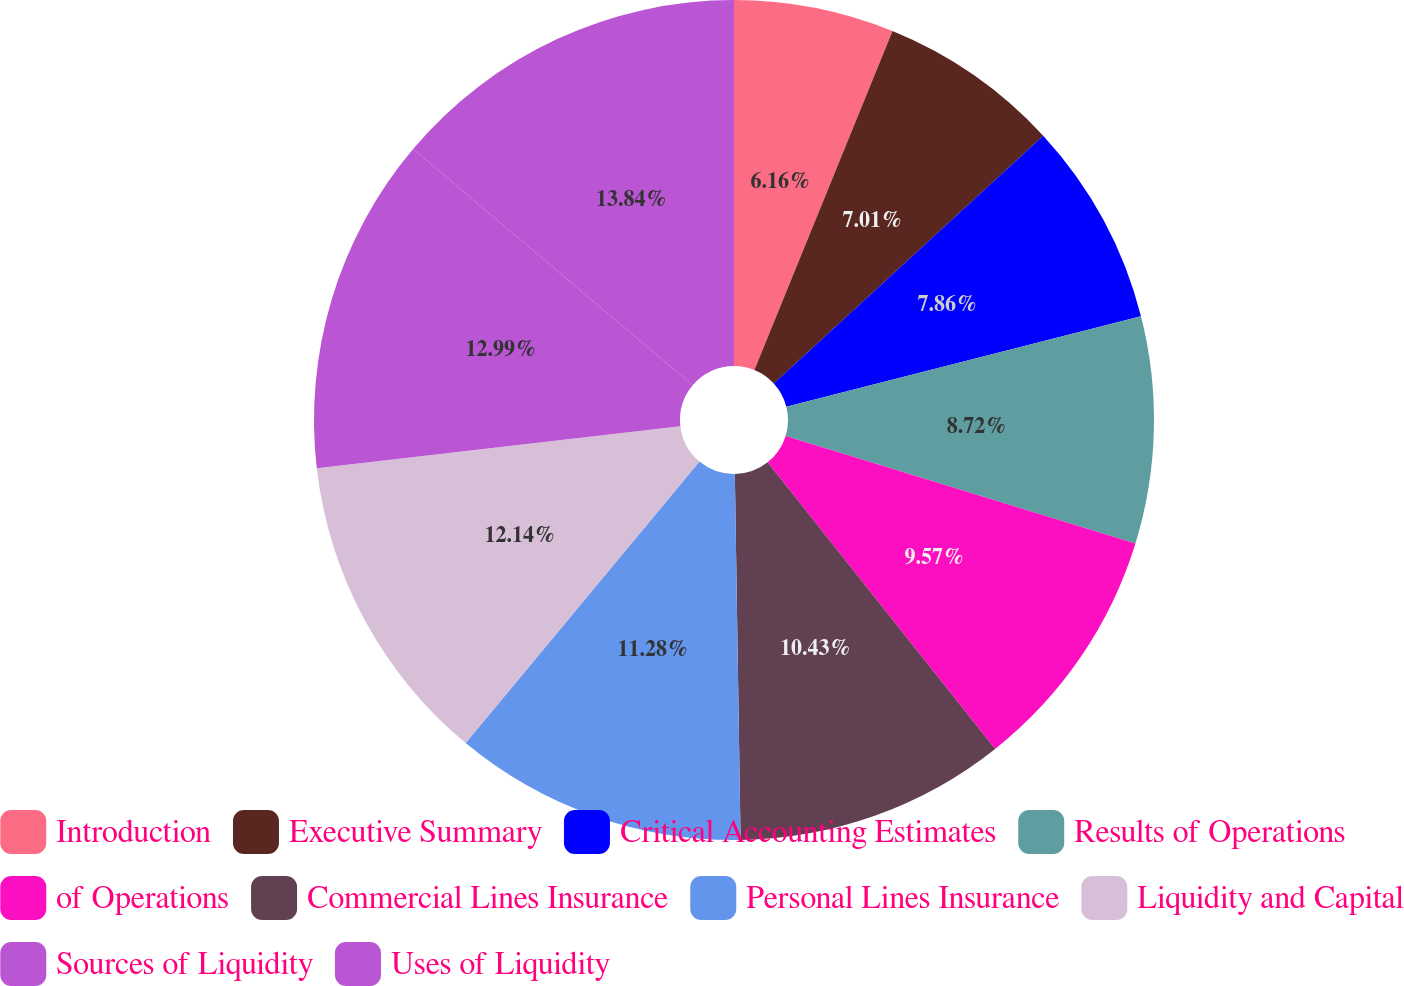Convert chart. <chart><loc_0><loc_0><loc_500><loc_500><pie_chart><fcel>Introduction<fcel>Executive Summary<fcel>Critical Accounting Estimates<fcel>Results of Operations<fcel>of Operations<fcel>Commercial Lines Insurance<fcel>Personal Lines Insurance<fcel>Liquidity and Capital<fcel>Sources of Liquidity<fcel>Uses of Liquidity<nl><fcel>6.16%<fcel>7.01%<fcel>7.86%<fcel>8.72%<fcel>9.57%<fcel>10.43%<fcel>11.28%<fcel>12.14%<fcel>12.99%<fcel>13.84%<nl></chart> 